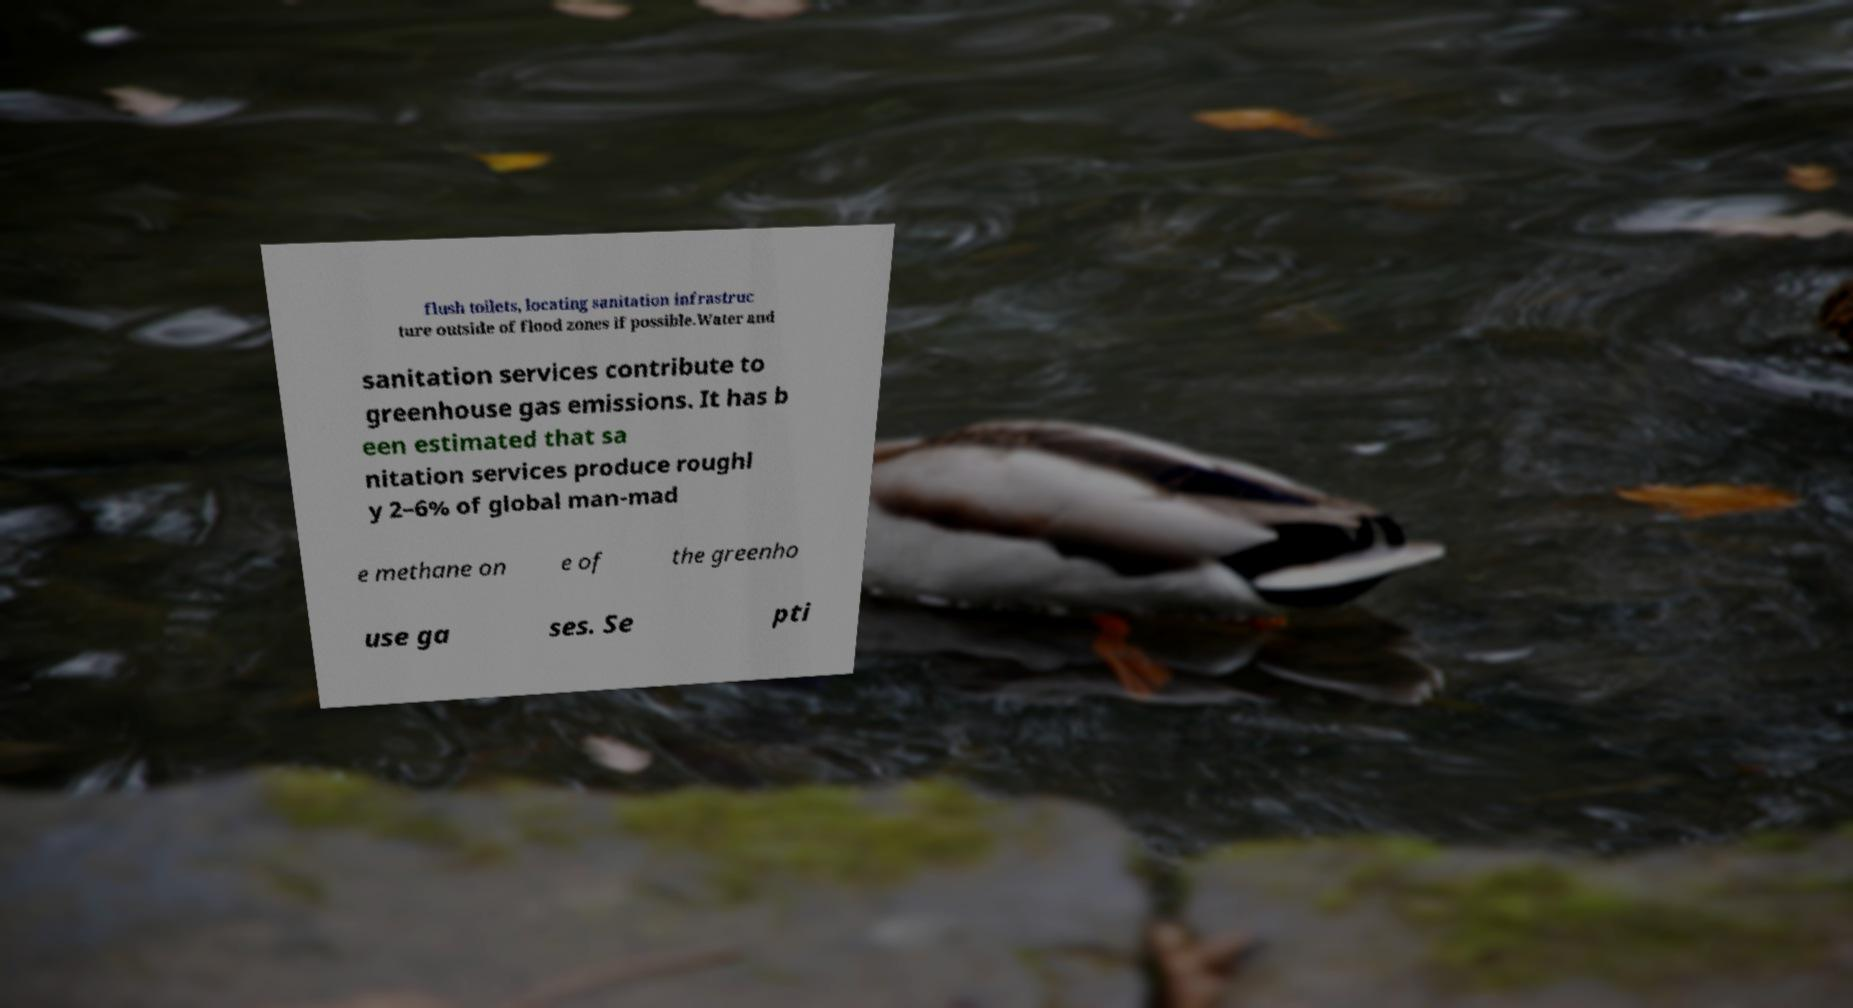Can you accurately transcribe the text from the provided image for me? flush toilets, locating sanitation infrastruc ture outside of flood zones if possible.Water and sanitation services contribute to greenhouse gas emissions. It has b een estimated that sa nitation services produce roughl y 2–6% of global man-mad e methane on e of the greenho use ga ses. Se pti 